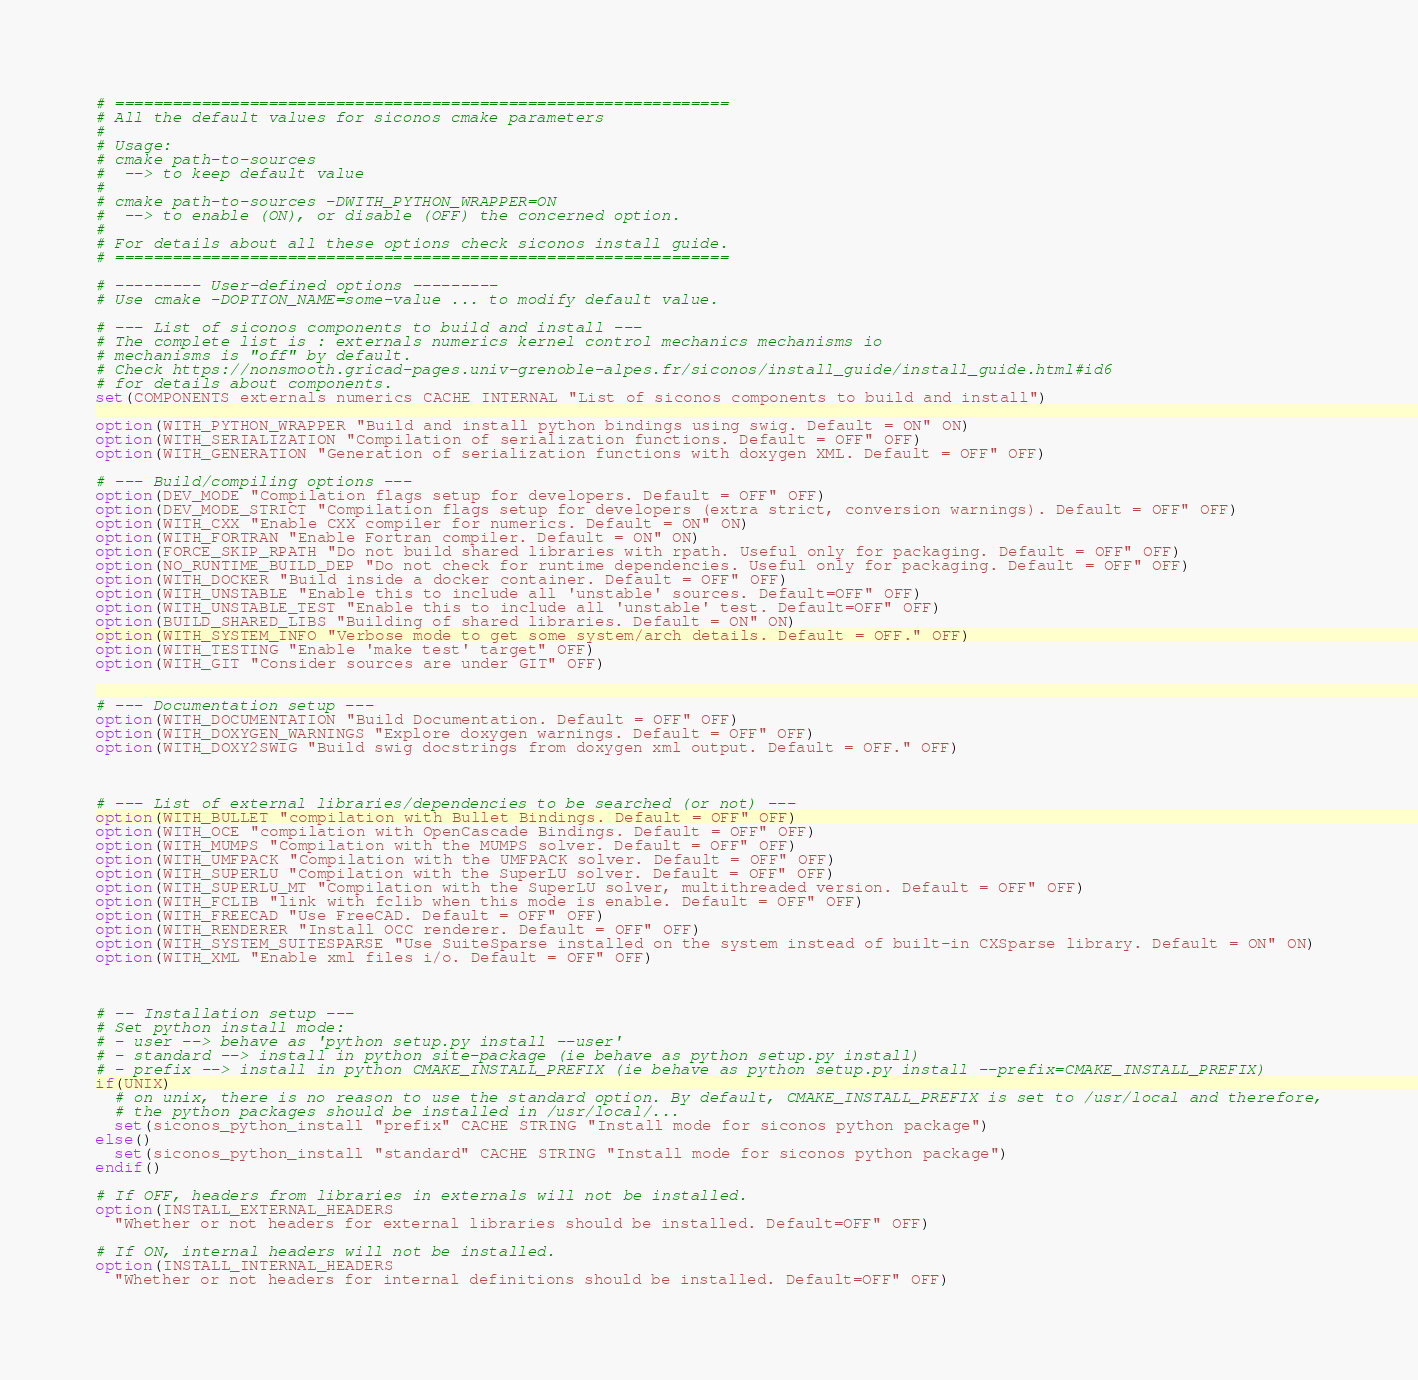<code> <loc_0><loc_0><loc_500><loc_500><_CMake_># ================================================================
# All the default values for siconos cmake parameters
#
# Usage:
# cmake path-to-sources
#  --> to keep default value
# 
# cmake path-to-sources -DWITH_PYTHON_WRAPPER=ON
#  --> to enable (ON), or disable (OFF) the concerned option.
#
# For details about all these options check siconos install guide.
# ================================================================

# --------- User-defined options ---------
# Use cmake -DOPTION_NAME=some-value ... to modify default value.

# --- List of siconos components to build and install ---
# The complete list is : externals numerics kernel control mechanics mechanisms io
# mechanisms is "off" by default.
# Check https://nonsmooth.gricad-pages.univ-grenoble-alpes.fr/siconos/install_guide/install_guide.html#id6
# for details about components.
set(COMPONENTS externals numerics CACHE INTERNAL "List of siconos components to build and install")

option(WITH_PYTHON_WRAPPER "Build and install python bindings using swig. Default = ON" ON)
option(WITH_SERIALIZATION "Compilation of serialization functions. Default = OFF" OFF)
option(WITH_GENERATION "Generation of serialization functions with doxygen XML. Default = OFF" OFF)

# --- Build/compiling options ---
option(DEV_MODE "Compilation flags setup for developers. Default = OFF" OFF)
option(DEV_MODE_STRICT "Compilation flags setup for developers (extra strict, conversion warnings). Default = OFF" OFF)
option(WITH_CXX "Enable CXX compiler for numerics. Default = ON" ON)
option(WITH_FORTRAN "Enable Fortran compiler. Default = ON" ON)
option(FORCE_SKIP_RPATH "Do not build shared libraries with rpath. Useful only for packaging. Default = OFF" OFF)
option(NO_RUNTIME_BUILD_DEP "Do not check for runtime dependencies. Useful only for packaging. Default = OFF" OFF)
option(WITH_DOCKER "Build inside a docker container. Default = OFF" OFF)
option(WITH_UNSTABLE "Enable this to include all 'unstable' sources. Default=OFF" OFF)
option(WITH_UNSTABLE_TEST "Enable this to include all 'unstable' test. Default=OFF" OFF)
option(BUILD_SHARED_LIBS "Building of shared libraries. Default = ON" ON)
option(WITH_SYSTEM_INFO "Verbose mode to get some system/arch details. Default = OFF." OFF)
option(WITH_TESTING "Enable 'make test' target" OFF)
option(WITH_GIT "Consider sources are under GIT" OFF)


# --- Documentation setup ---
option(WITH_DOCUMENTATION "Build Documentation. Default = OFF" OFF)
option(WITH_DOXYGEN_WARNINGS "Explore doxygen warnings. Default = OFF" OFF)
option(WITH_DOXY2SWIG "Build swig docstrings from doxygen xml output. Default = OFF." OFF)



# --- List of external libraries/dependencies to be searched (or not) ---
option(WITH_BULLET "compilation with Bullet Bindings. Default = OFF" OFF)
option(WITH_OCE "compilation with OpenCascade Bindings. Default = OFF" OFF)
option(WITH_MUMPS "Compilation with the MUMPS solver. Default = OFF" OFF)
option(WITH_UMFPACK "Compilation with the UMFPACK solver. Default = OFF" OFF)
option(WITH_SUPERLU "Compilation with the SuperLU solver. Default = OFF" OFF)
option(WITH_SUPERLU_MT "Compilation with the SuperLU solver, multithreaded version. Default = OFF" OFF)
option(WITH_FCLIB "link with fclib when this mode is enable. Default = OFF" OFF)
option(WITH_FREECAD "Use FreeCAD. Default = OFF" OFF)
option(WITH_RENDERER "Install OCC renderer. Default = OFF" OFF)
option(WITH_SYSTEM_SUITESPARSE "Use SuiteSparse installed on the system instead of built-in CXSparse library. Default = ON" ON)
option(WITH_XML "Enable xml files i/o. Default = OFF" OFF)



# -- Installation setup ---
# Set python install mode:
# - user --> behave as 'python setup.py install --user'
# - standard --> install in python site-package (ie behave as python setup.py install)
# - prefix --> install in python CMAKE_INSTALL_PREFIX (ie behave as python setup.py install --prefix=CMAKE_INSTALL_PREFIX)
if(UNIX)
  # on unix, there is no reason to use the standard option. By default, CMAKE_INSTALL_PREFIX is set to /usr/local and therefore,
  # the python packages should be installed in /usr/local/...
  set(siconos_python_install "prefix" CACHE STRING "Install mode for siconos python package")
else()
  set(siconos_python_install "standard" CACHE STRING "Install mode for siconos python package")
endif()

# If OFF, headers from libraries in externals will not be installed.
option(INSTALL_EXTERNAL_HEADERS
  "Whether or not headers for external libraries should be installed. Default=OFF" OFF)

# If ON, internal headers will not be installed.
option(INSTALL_INTERNAL_HEADERS
  "Whether or not headers for internal definitions should be installed. Default=OFF" OFF)

</code> 